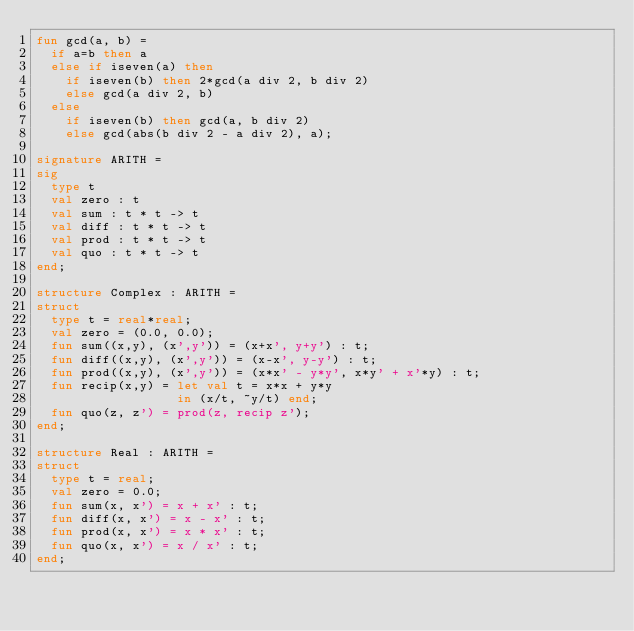Convert code to text. <code><loc_0><loc_0><loc_500><loc_500><_SML_>fun gcd(a, b) =
  if a=b then a
  else if iseven(a) then
    if iseven(b) then 2*gcd(a div 2, b div 2)
    else gcd(a div 2, b)
  else
    if iseven(b) then gcd(a, b div 2)
    else gcd(abs(b div 2 - a div 2), a);

signature ARITH =
sig
  type t
  val zero : t
  val sum : t * t -> t
  val diff : t * t -> t
  val prod : t * t -> t
  val quo : t * t -> t
end;

structure Complex : ARITH =
struct
  type t = real*real;
  val zero = (0.0, 0.0);
  fun sum((x,y), (x',y')) = (x+x', y+y') : t;
  fun diff((x,y), (x',y')) = (x-x', y-y') : t;
  fun prod((x,y), (x',y')) = (x*x' - y*y', x*y' + x'*y) : t;
  fun recip(x,y) = let val t = x*x + y*y
                   in (x/t, ~y/t) end;
  fun quo(z, z') = prod(z, recip z');
end;

structure Real : ARITH =
struct
  type t = real;
  val zero = 0.0;
  fun sum(x, x') = x + x' : t;
  fun diff(x, x') = x - x' : t;
  fun prod(x, x') = x * x' : t;
  fun quo(x, x') = x / x' : t;
end;
</code> 